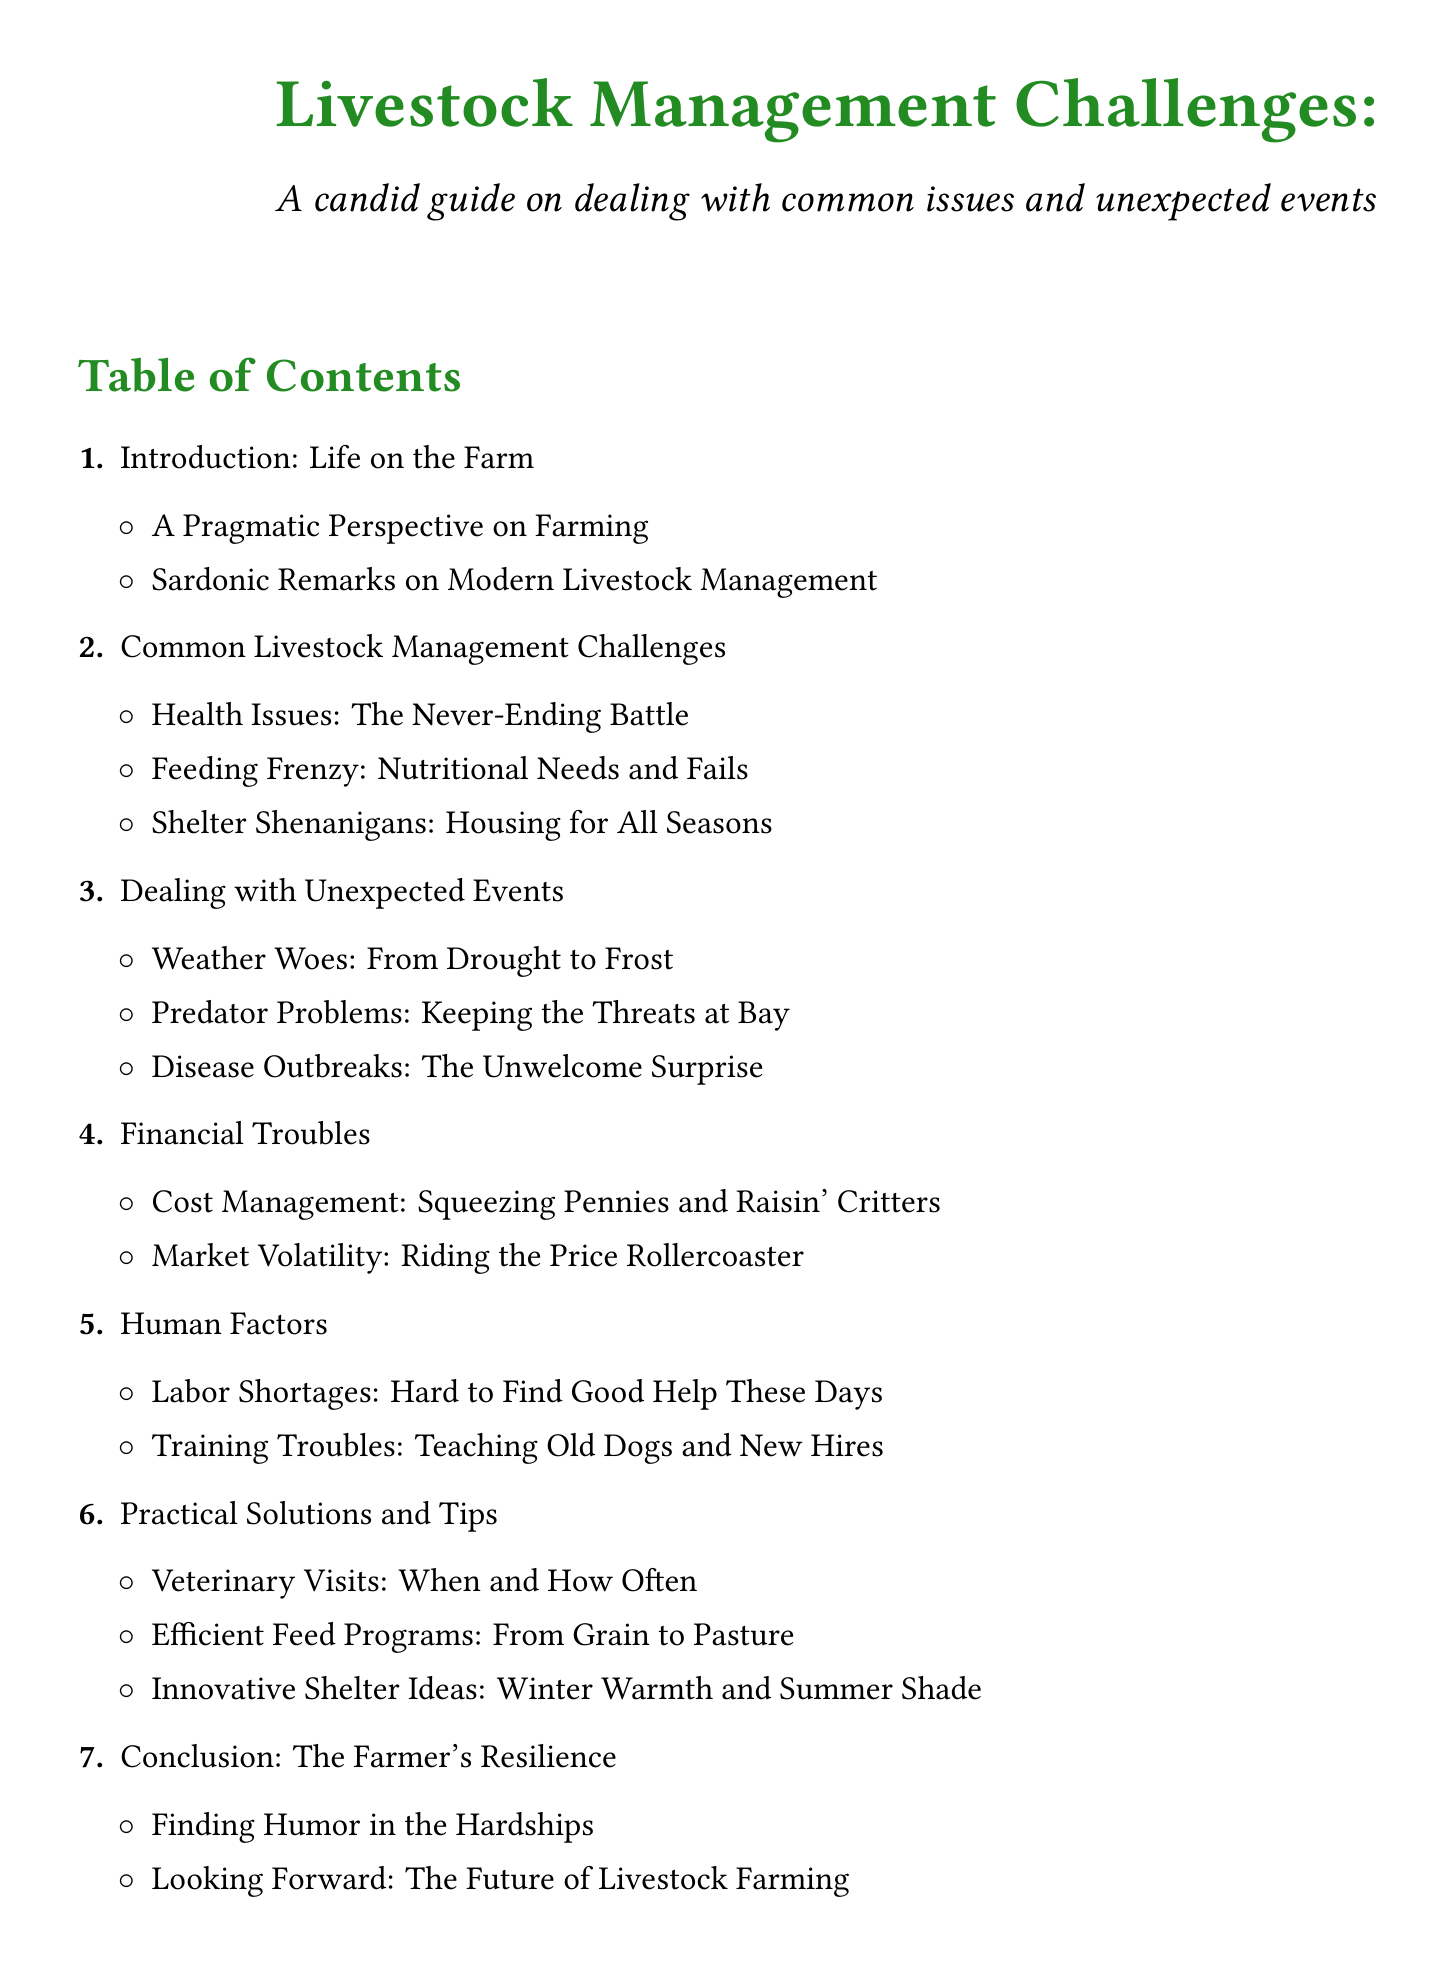What is the first section of the document? The first section introduces the topic and provides insights about life on the farm.
Answer: Introduction: Life on the Farm How many common livestock management challenges are listed? The document outlines three specific challenges related to livestock management.
Answer: Three What are the two main types of unexpected events discussed? The document categorizes unexpected events into weather issues and biological threats to livestock.
Answer: Weather Woes and Disease Outbreaks What challenge is related to financial issues? This section deals with the economic aspects impacting livestock management.
Answer: Financial Troubles What does the conclusion focus on? The conclusion reflects on resilience and future outlooks in farming, combining personal humor and forward-thinking.
Answer: The Farmer's Resilience 